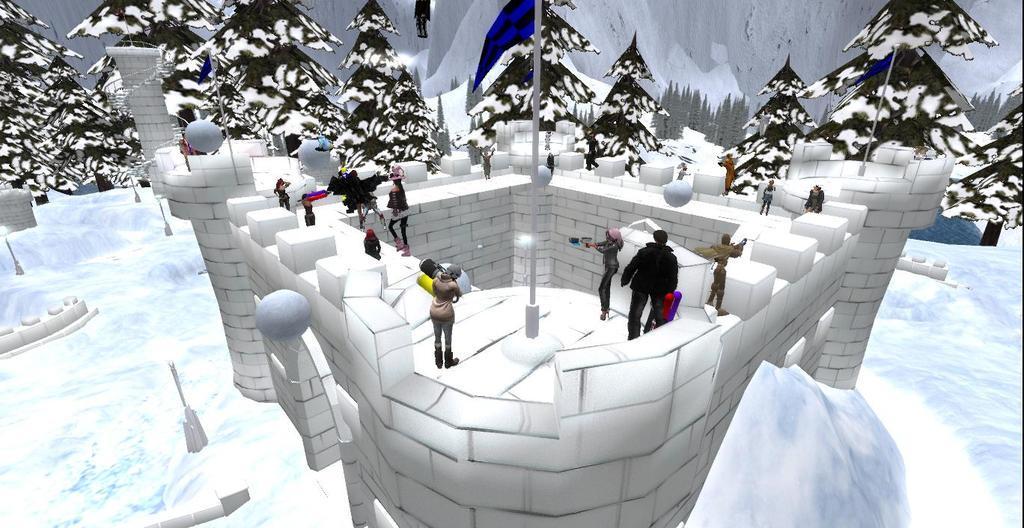Can you describe this image briefly? This is an animated image. There are a few people, poles, pillars, trees. We can see a fort and the ground covered with snow and some objects. 